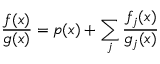Convert formula to latex. <formula><loc_0><loc_0><loc_500><loc_500>{ \frac { f ( x ) } { g ( x ) } } = p ( x ) + \sum _ { j } { \frac { f _ { j } ( x ) } { g _ { j } ( x ) } }</formula> 